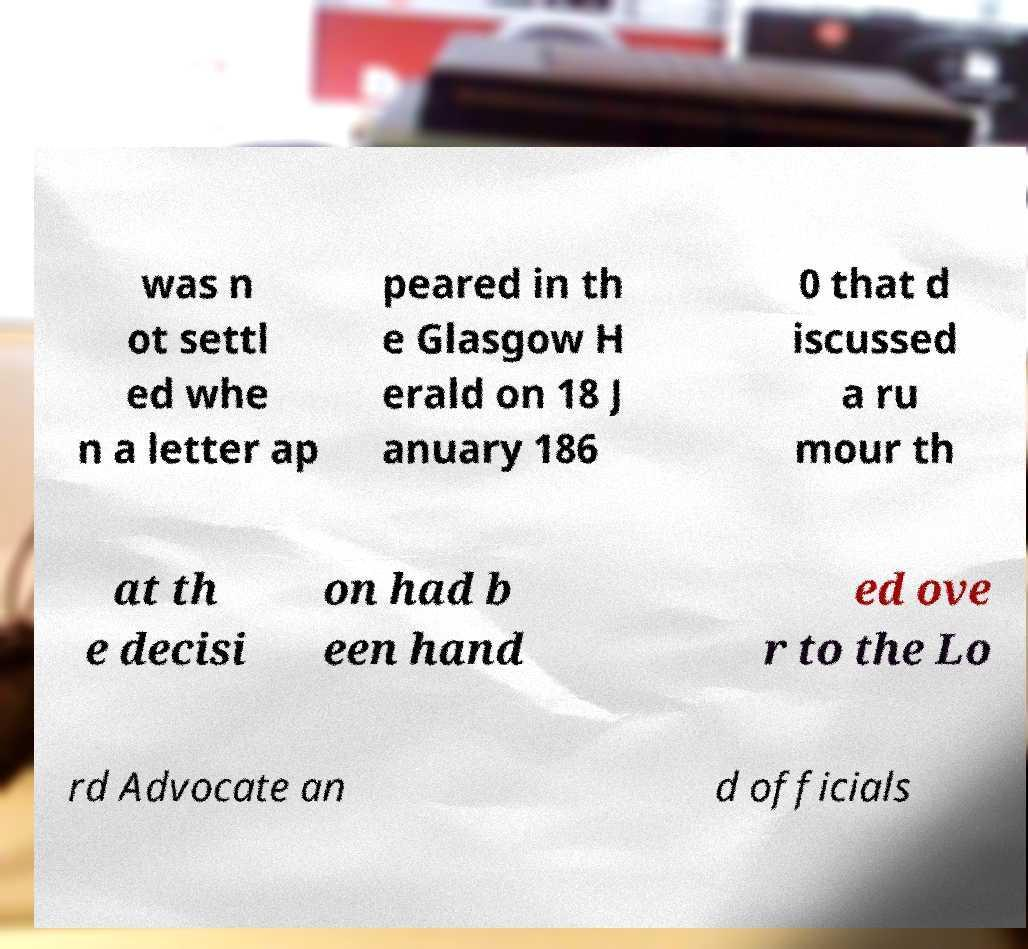Could you assist in decoding the text presented in this image and type it out clearly? was n ot settl ed whe n a letter ap peared in th e Glasgow H erald on 18 J anuary 186 0 that d iscussed a ru mour th at th e decisi on had b een hand ed ove r to the Lo rd Advocate an d officials 